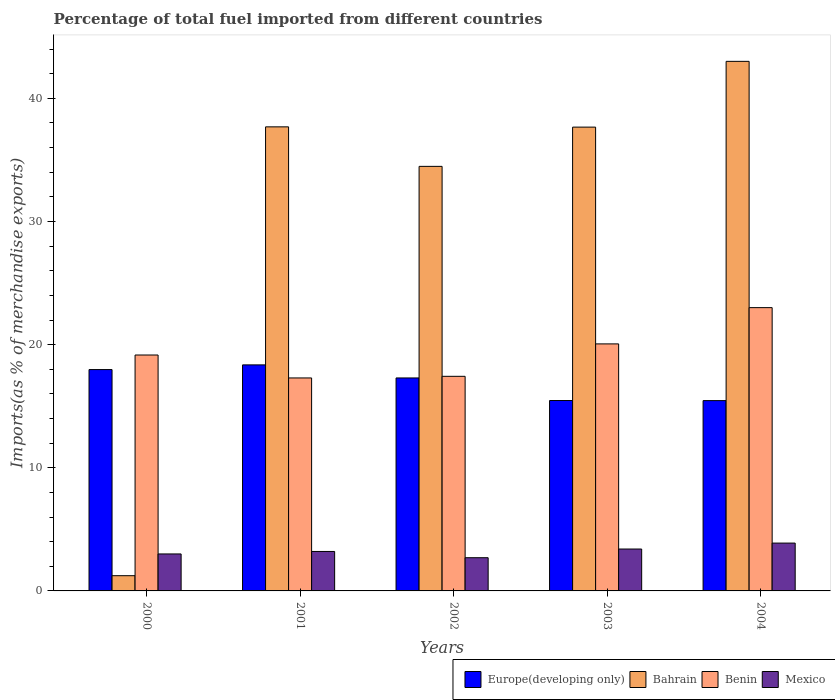How many different coloured bars are there?
Your answer should be compact. 4. How many groups of bars are there?
Your answer should be very brief. 5. Are the number of bars on each tick of the X-axis equal?
Provide a succinct answer. Yes. How many bars are there on the 5th tick from the right?
Offer a terse response. 4. What is the label of the 3rd group of bars from the left?
Your answer should be very brief. 2002. What is the percentage of imports to different countries in Benin in 2001?
Offer a very short reply. 17.3. Across all years, what is the maximum percentage of imports to different countries in Benin?
Your answer should be very brief. 23.01. Across all years, what is the minimum percentage of imports to different countries in Mexico?
Keep it short and to the point. 2.7. What is the total percentage of imports to different countries in Europe(developing only) in the graph?
Offer a very short reply. 84.55. What is the difference between the percentage of imports to different countries in Benin in 2001 and that in 2004?
Provide a short and direct response. -5.71. What is the difference between the percentage of imports to different countries in Bahrain in 2003 and the percentage of imports to different countries in Benin in 2001?
Offer a very short reply. 20.37. What is the average percentage of imports to different countries in Bahrain per year?
Offer a terse response. 30.81. In the year 2004, what is the difference between the percentage of imports to different countries in Bahrain and percentage of imports to different countries in Mexico?
Keep it short and to the point. 39.12. What is the ratio of the percentage of imports to different countries in Mexico in 2003 to that in 2004?
Offer a terse response. 0.88. Is the percentage of imports to different countries in Bahrain in 2000 less than that in 2003?
Ensure brevity in your answer.  Yes. Is the difference between the percentage of imports to different countries in Bahrain in 2003 and 2004 greater than the difference between the percentage of imports to different countries in Mexico in 2003 and 2004?
Your answer should be very brief. No. What is the difference between the highest and the second highest percentage of imports to different countries in Europe(developing only)?
Your answer should be very brief. 0.38. What is the difference between the highest and the lowest percentage of imports to different countries in Mexico?
Your answer should be compact. 1.19. Is the sum of the percentage of imports to different countries in Benin in 2002 and 2003 greater than the maximum percentage of imports to different countries in Europe(developing only) across all years?
Your response must be concise. Yes. What does the 1st bar from the left in 2003 represents?
Your answer should be very brief. Europe(developing only). What does the 2nd bar from the right in 2001 represents?
Your response must be concise. Benin. Is it the case that in every year, the sum of the percentage of imports to different countries in Bahrain and percentage of imports to different countries in Europe(developing only) is greater than the percentage of imports to different countries in Mexico?
Offer a very short reply. Yes. Are all the bars in the graph horizontal?
Give a very brief answer. No. How many years are there in the graph?
Make the answer very short. 5. Are the values on the major ticks of Y-axis written in scientific E-notation?
Your response must be concise. No. Where does the legend appear in the graph?
Keep it short and to the point. Bottom right. What is the title of the graph?
Provide a short and direct response. Percentage of total fuel imported from different countries. What is the label or title of the Y-axis?
Make the answer very short. Imports(as % of merchandise exports). What is the Imports(as % of merchandise exports) of Europe(developing only) in 2000?
Offer a terse response. 17.98. What is the Imports(as % of merchandise exports) of Bahrain in 2000?
Ensure brevity in your answer.  1.24. What is the Imports(as % of merchandise exports) in Benin in 2000?
Provide a short and direct response. 19.16. What is the Imports(as % of merchandise exports) in Mexico in 2000?
Ensure brevity in your answer.  3. What is the Imports(as % of merchandise exports) in Europe(developing only) in 2001?
Your response must be concise. 18.36. What is the Imports(as % of merchandise exports) of Bahrain in 2001?
Offer a terse response. 37.69. What is the Imports(as % of merchandise exports) in Benin in 2001?
Give a very brief answer. 17.3. What is the Imports(as % of merchandise exports) in Mexico in 2001?
Your answer should be very brief. 3.21. What is the Imports(as % of merchandise exports) in Europe(developing only) in 2002?
Provide a short and direct response. 17.3. What is the Imports(as % of merchandise exports) of Bahrain in 2002?
Your response must be concise. 34.48. What is the Imports(as % of merchandise exports) in Benin in 2002?
Your answer should be compact. 17.43. What is the Imports(as % of merchandise exports) of Mexico in 2002?
Your answer should be very brief. 2.7. What is the Imports(as % of merchandise exports) in Europe(developing only) in 2003?
Provide a short and direct response. 15.46. What is the Imports(as % of merchandise exports) of Bahrain in 2003?
Your answer should be very brief. 37.66. What is the Imports(as % of merchandise exports) of Benin in 2003?
Your response must be concise. 20.06. What is the Imports(as % of merchandise exports) of Mexico in 2003?
Make the answer very short. 3.4. What is the Imports(as % of merchandise exports) in Europe(developing only) in 2004?
Provide a succinct answer. 15.45. What is the Imports(as % of merchandise exports) of Bahrain in 2004?
Offer a very short reply. 43.01. What is the Imports(as % of merchandise exports) in Benin in 2004?
Your response must be concise. 23.01. What is the Imports(as % of merchandise exports) in Mexico in 2004?
Your answer should be compact. 3.88. Across all years, what is the maximum Imports(as % of merchandise exports) of Europe(developing only)?
Provide a succinct answer. 18.36. Across all years, what is the maximum Imports(as % of merchandise exports) of Bahrain?
Make the answer very short. 43.01. Across all years, what is the maximum Imports(as % of merchandise exports) in Benin?
Give a very brief answer. 23.01. Across all years, what is the maximum Imports(as % of merchandise exports) in Mexico?
Ensure brevity in your answer.  3.88. Across all years, what is the minimum Imports(as % of merchandise exports) in Europe(developing only)?
Your response must be concise. 15.45. Across all years, what is the minimum Imports(as % of merchandise exports) of Bahrain?
Provide a short and direct response. 1.24. Across all years, what is the minimum Imports(as % of merchandise exports) of Benin?
Give a very brief answer. 17.3. Across all years, what is the minimum Imports(as % of merchandise exports) in Mexico?
Provide a short and direct response. 2.7. What is the total Imports(as % of merchandise exports) of Europe(developing only) in the graph?
Provide a short and direct response. 84.55. What is the total Imports(as % of merchandise exports) in Bahrain in the graph?
Your response must be concise. 154.07. What is the total Imports(as % of merchandise exports) in Benin in the graph?
Your answer should be very brief. 96.95. What is the total Imports(as % of merchandise exports) in Mexico in the graph?
Keep it short and to the point. 16.19. What is the difference between the Imports(as % of merchandise exports) in Europe(developing only) in 2000 and that in 2001?
Make the answer very short. -0.38. What is the difference between the Imports(as % of merchandise exports) in Bahrain in 2000 and that in 2001?
Your response must be concise. -36.45. What is the difference between the Imports(as % of merchandise exports) in Benin in 2000 and that in 2001?
Your response must be concise. 1.86. What is the difference between the Imports(as % of merchandise exports) in Mexico in 2000 and that in 2001?
Keep it short and to the point. -0.2. What is the difference between the Imports(as % of merchandise exports) of Europe(developing only) in 2000 and that in 2002?
Keep it short and to the point. 0.68. What is the difference between the Imports(as % of merchandise exports) of Bahrain in 2000 and that in 2002?
Give a very brief answer. -33.24. What is the difference between the Imports(as % of merchandise exports) of Benin in 2000 and that in 2002?
Your answer should be very brief. 1.73. What is the difference between the Imports(as % of merchandise exports) in Mexico in 2000 and that in 2002?
Provide a succinct answer. 0.31. What is the difference between the Imports(as % of merchandise exports) in Europe(developing only) in 2000 and that in 2003?
Your response must be concise. 2.51. What is the difference between the Imports(as % of merchandise exports) of Bahrain in 2000 and that in 2003?
Offer a very short reply. -36.43. What is the difference between the Imports(as % of merchandise exports) in Benin in 2000 and that in 2003?
Your response must be concise. -0.9. What is the difference between the Imports(as % of merchandise exports) in Mexico in 2000 and that in 2003?
Give a very brief answer. -0.4. What is the difference between the Imports(as % of merchandise exports) in Europe(developing only) in 2000 and that in 2004?
Offer a very short reply. 2.52. What is the difference between the Imports(as % of merchandise exports) in Bahrain in 2000 and that in 2004?
Offer a very short reply. -41.77. What is the difference between the Imports(as % of merchandise exports) in Benin in 2000 and that in 2004?
Offer a terse response. -3.85. What is the difference between the Imports(as % of merchandise exports) in Mexico in 2000 and that in 2004?
Your answer should be very brief. -0.88. What is the difference between the Imports(as % of merchandise exports) of Europe(developing only) in 2001 and that in 2002?
Your response must be concise. 1.06. What is the difference between the Imports(as % of merchandise exports) of Bahrain in 2001 and that in 2002?
Make the answer very short. 3.21. What is the difference between the Imports(as % of merchandise exports) of Benin in 2001 and that in 2002?
Offer a terse response. -0.13. What is the difference between the Imports(as % of merchandise exports) of Mexico in 2001 and that in 2002?
Give a very brief answer. 0.51. What is the difference between the Imports(as % of merchandise exports) of Europe(developing only) in 2001 and that in 2003?
Offer a very short reply. 2.89. What is the difference between the Imports(as % of merchandise exports) of Bahrain in 2001 and that in 2003?
Ensure brevity in your answer.  0.02. What is the difference between the Imports(as % of merchandise exports) of Benin in 2001 and that in 2003?
Your answer should be compact. -2.76. What is the difference between the Imports(as % of merchandise exports) in Mexico in 2001 and that in 2003?
Offer a very short reply. -0.2. What is the difference between the Imports(as % of merchandise exports) of Europe(developing only) in 2001 and that in 2004?
Give a very brief answer. 2.9. What is the difference between the Imports(as % of merchandise exports) of Bahrain in 2001 and that in 2004?
Ensure brevity in your answer.  -5.32. What is the difference between the Imports(as % of merchandise exports) in Benin in 2001 and that in 2004?
Provide a succinct answer. -5.71. What is the difference between the Imports(as % of merchandise exports) of Mexico in 2001 and that in 2004?
Provide a succinct answer. -0.68. What is the difference between the Imports(as % of merchandise exports) of Europe(developing only) in 2002 and that in 2003?
Make the answer very short. 1.83. What is the difference between the Imports(as % of merchandise exports) in Bahrain in 2002 and that in 2003?
Your response must be concise. -3.19. What is the difference between the Imports(as % of merchandise exports) of Benin in 2002 and that in 2003?
Keep it short and to the point. -2.63. What is the difference between the Imports(as % of merchandise exports) in Mexico in 2002 and that in 2003?
Provide a succinct answer. -0.71. What is the difference between the Imports(as % of merchandise exports) of Europe(developing only) in 2002 and that in 2004?
Make the answer very short. 1.84. What is the difference between the Imports(as % of merchandise exports) in Bahrain in 2002 and that in 2004?
Provide a short and direct response. -8.53. What is the difference between the Imports(as % of merchandise exports) in Benin in 2002 and that in 2004?
Your response must be concise. -5.58. What is the difference between the Imports(as % of merchandise exports) of Mexico in 2002 and that in 2004?
Ensure brevity in your answer.  -1.19. What is the difference between the Imports(as % of merchandise exports) of Europe(developing only) in 2003 and that in 2004?
Your response must be concise. 0.01. What is the difference between the Imports(as % of merchandise exports) in Bahrain in 2003 and that in 2004?
Offer a terse response. -5.34. What is the difference between the Imports(as % of merchandise exports) of Benin in 2003 and that in 2004?
Make the answer very short. -2.95. What is the difference between the Imports(as % of merchandise exports) in Mexico in 2003 and that in 2004?
Your answer should be very brief. -0.48. What is the difference between the Imports(as % of merchandise exports) of Europe(developing only) in 2000 and the Imports(as % of merchandise exports) of Bahrain in 2001?
Give a very brief answer. -19.71. What is the difference between the Imports(as % of merchandise exports) of Europe(developing only) in 2000 and the Imports(as % of merchandise exports) of Benin in 2001?
Provide a short and direct response. 0.68. What is the difference between the Imports(as % of merchandise exports) of Europe(developing only) in 2000 and the Imports(as % of merchandise exports) of Mexico in 2001?
Keep it short and to the point. 14.77. What is the difference between the Imports(as % of merchandise exports) in Bahrain in 2000 and the Imports(as % of merchandise exports) in Benin in 2001?
Your response must be concise. -16.06. What is the difference between the Imports(as % of merchandise exports) in Bahrain in 2000 and the Imports(as % of merchandise exports) in Mexico in 2001?
Provide a short and direct response. -1.97. What is the difference between the Imports(as % of merchandise exports) in Benin in 2000 and the Imports(as % of merchandise exports) in Mexico in 2001?
Offer a terse response. 15.95. What is the difference between the Imports(as % of merchandise exports) in Europe(developing only) in 2000 and the Imports(as % of merchandise exports) in Bahrain in 2002?
Offer a terse response. -16.5. What is the difference between the Imports(as % of merchandise exports) in Europe(developing only) in 2000 and the Imports(as % of merchandise exports) in Benin in 2002?
Keep it short and to the point. 0.55. What is the difference between the Imports(as % of merchandise exports) in Europe(developing only) in 2000 and the Imports(as % of merchandise exports) in Mexico in 2002?
Your answer should be very brief. 15.28. What is the difference between the Imports(as % of merchandise exports) in Bahrain in 2000 and the Imports(as % of merchandise exports) in Benin in 2002?
Your answer should be compact. -16.19. What is the difference between the Imports(as % of merchandise exports) of Bahrain in 2000 and the Imports(as % of merchandise exports) of Mexico in 2002?
Give a very brief answer. -1.46. What is the difference between the Imports(as % of merchandise exports) of Benin in 2000 and the Imports(as % of merchandise exports) of Mexico in 2002?
Your response must be concise. 16.46. What is the difference between the Imports(as % of merchandise exports) in Europe(developing only) in 2000 and the Imports(as % of merchandise exports) in Bahrain in 2003?
Your response must be concise. -19.69. What is the difference between the Imports(as % of merchandise exports) in Europe(developing only) in 2000 and the Imports(as % of merchandise exports) in Benin in 2003?
Offer a terse response. -2.08. What is the difference between the Imports(as % of merchandise exports) of Europe(developing only) in 2000 and the Imports(as % of merchandise exports) of Mexico in 2003?
Your answer should be very brief. 14.57. What is the difference between the Imports(as % of merchandise exports) of Bahrain in 2000 and the Imports(as % of merchandise exports) of Benin in 2003?
Make the answer very short. -18.82. What is the difference between the Imports(as % of merchandise exports) of Bahrain in 2000 and the Imports(as % of merchandise exports) of Mexico in 2003?
Ensure brevity in your answer.  -2.17. What is the difference between the Imports(as % of merchandise exports) of Benin in 2000 and the Imports(as % of merchandise exports) of Mexico in 2003?
Give a very brief answer. 15.76. What is the difference between the Imports(as % of merchandise exports) of Europe(developing only) in 2000 and the Imports(as % of merchandise exports) of Bahrain in 2004?
Provide a succinct answer. -25.03. What is the difference between the Imports(as % of merchandise exports) of Europe(developing only) in 2000 and the Imports(as % of merchandise exports) of Benin in 2004?
Give a very brief answer. -5.03. What is the difference between the Imports(as % of merchandise exports) of Europe(developing only) in 2000 and the Imports(as % of merchandise exports) of Mexico in 2004?
Your response must be concise. 14.09. What is the difference between the Imports(as % of merchandise exports) of Bahrain in 2000 and the Imports(as % of merchandise exports) of Benin in 2004?
Ensure brevity in your answer.  -21.77. What is the difference between the Imports(as % of merchandise exports) in Bahrain in 2000 and the Imports(as % of merchandise exports) in Mexico in 2004?
Provide a short and direct response. -2.65. What is the difference between the Imports(as % of merchandise exports) in Benin in 2000 and the Imports(as % of merchandise exports) in Mexico in 2004?
Provide a succinct answer. 15.27. What is the difference between the Imports(as % of merchandise exports) in Europe(developing only) in 2001 and the Imports(as % of merchandise exports) in Bahrain in 2002?
Provide a succinct answer. -16.12. What is the difference between the Imports(as % of merchandise exports) in Europe(developing only) in 2001 and the Imports(as % of merchandise exports) in Benin in 2002?
Your response must be concise. 0.93. What is the difference between the Imports(as % of merchandise exports) of Europe(developing only) in 2001 and the Imports(as % of merchandise exports) of Mexico in 2002?
Make the answer very short. 15.66. What is the difference between the Imports(as % of merchandise exports) of Bahrain in 2001 and the Imports(as % of merchandise exports) of Benin in 2002?
Keep it short and to the point. 20.26. What is the difference between the Imports(as % of merchandise exports) in Bahrain in 2001 and the Imports(as % of merchandise exports) in Mexico in 2002?
Offer a terse response. 34.99. What is the difference between the Imports(as % of merchandise exports) in Benin in 2001 and the Imports(as % of merchandise exports) in Mexico in 2002?
Offer a very short reply. 14.6. What is the difference between the Imports(as % of merchandise exports) in Europe(developing only) in 2001 and the Imports(as % of merchandise exports) in Bahrain in 2003?
Offer a very short reply. -19.31. What is the difference between the Imports(as % of merchandise exports) of Europe(developing only) in 2001 and the Imports(as % of merchandise exports) of Benin in 2003?
Provide a short and direct response. -1.7. What is the difference between the Imports(as % of merchandise exports) in Europe(developing only) in 2001 and the Imports(as % of merchandise exports) in Mexico in 2003?
Your answer should be very brief. 14.95. What is the difference between the Imports(as % of merchandise exports) of Bahrain in 2001 and the Imports(as % of merchandise exports) of Benin in 2003?
Offer a very short reply. 17.63. What is the difference between the Imports(as % of merchandise exports) of Bahrain in 2001 and the Imports(as % of merchandise exports) of Mexico in 2003?
Your answer should be compact. 34.28. What is the difference between the Imports(as % of merchandise exports) in Benin in 2001 and the Imports(as % of merchandise exports) in Mexico in 2003?
Your answer should be compact. 13.89. What is the difference between the Imports(as % of merchandise exports) of Europe(developing only) in 2001 and the Imports(as % of merchandise exports) of Bahrain in 2004?
Keep it short and to the point. -24.65. What is the difference between the Imports(as % of merchandise exports) in Europe(developing only) in 2001 and the Imports(as % of merchandise exports) in Benin in 2004?
Make the answer very short. -4.65. What is the difference between the Imports(as % of merchandise exports) of Europe(developing only) in 2001 and the Imports(as % of merchandise exports) of Mexico in 2004?
Ensure brevity in your answer.  14.47. What is the difference between the Imports(as % of merchandise exports) in Bahrain in 2001 and the Imports(as % of merchandise exports) in Benin in 2004?
Offer a very short reply. 14.68. What is the difference between the Imports(as % of merchandise exports) in Bahrain in 2001 and the Imports(as % of merchandise exports) in Mexico in 2004?
Provide a succinct answer. 33.8. What is the difference between the Imports(as % of merchandise exports) of Benin in 2001 and the Imports(as % of merchandise exports) of Mexico in 2004?
Provide a short and direct response. 13.41. What is the difference between the Imports(as % of merchandise exports) in Europe(developing only) in 2002 and the Imports(as % of merchandise exports) in Bahrain in 2003?
Make the answer very short. -20.37. What is the difference between the Imports(as % of merchandise exports) of Europe(developing only) in 2002 and the Imports(as % of merchandise exports) of Benin in 2003?
Offer a terse response. -2.76. What is the difference between the Imports(as % of merchandise exports) of Europe(developing only) in 2002 and the Imports(as % of merchandise exports) of Mexico in 2003?
Your response must be concise. 13.89. What is the difference between the Imports(as % of merchandise exports) of Bahrain in 2002 and the Imports(as % of merchandise exports) of Benin in 2003?
Ensure brevity in your answer.  14.42. What is the difference between the Imports(as % of merchandise exports) of Bahrain in 2002 and the Imports(as % of merchandise exports) of Mexico in 2003?
Offer a very short reply. 31.07. What is the difference between the Imports(as % of merchandise exports) of Benin in 2002 and the Imports(as % of merchandise exports) of Mexico in 2003?
Give a very brief answer. 14.02. What is the difference between the Imports(as % of merchandise exports) of Europe(developing only) in 2002 and the Imports(as % of merchandise exports) of Bahrain in 2004?
Make the answer very short. -25.71. What is the difference between the Imports(as % of merchandise exports) in Europe(developing only) in 2002 and the Imports(as % of merchandise exports) in Benin in 2004?
Provide a short and direct response. -5.71. What is the difference between the Imports(as % of merchandise exports) of Europe(developing only) in 2002 and the Imports(as % of merchandise exports) of Mexico in 2004?
Offer a very short reply. 13.41. What is the difference between the Imports(as % of merchandise exports) of Bahrain in 2002 and the Imports(as % of merchandise exports) of Benin in 2004?
Offer a terse response. 11.47. What is the difference between the Imports(as % of merchandise exports) in Bahrain in 2002 and the Imports(as % of merchandise exports) in Mexico in 2004?
Offer a terse response. 30.59. What is the difference between the Imports(as % of merchandise exports) of Benin in 2002 and the Imports(as % of merchandise exports) of Mexico in 2004?
Give a very brief answer. 13.54. What is the difference between the Imports(as % of merchandise exports) of Europe(developing only) in 2003 and the Imports(as % of merchandise exports) of Bahrain in 2004?
Ensure brevity in your answer.  -27.54. What is the difference between the Imports(as % of merchandise exports) in Europe(developing only) in 2003 and the Imports(as % of merchandise exports) in Benin in 2004?
Give a very brief answer. -7.54. What is the difference between the Imports(as % of merchandise exports) of Europe(developing only) in 2003 and the Imports(as % of merchandise exports) of Mexico in 2004?
Give a very brief answer. 11.58. What is the difference between the Imports(as % of merchandise exports) of Bahrain in 2003 and the Imports(as % of merchandise exports) of Benin in 2004?
Give a very brief answer. 14.66. What is the difference between the Imports(as % of merchandise exports) of Bahrain in 2003 and the Imports(as % of merchandise exports) of Mexico in 2004?
Make the answer very short. 33.78. What is the difference between the Imports(as % of merchandise exports) of Benin in 2003 and the Imports(as % of merchandise exports) of Mexico in 2004?
Offer a terse response. 16.18. What is the average Imports(as % of merchandise exports) of Europe(developing only) per year?
Offer a terse response. 16.91. What is the average Imports(as % of merchandise exports) of Bahrain per year?
Provide a short and direct response. 30.81. What is the average Imports(as % of merchandise exports) of Benin per year?
Offer a terse response. 19.39. What is the average Imports(as % of merchandise exports) in Mexico per year?
Your answer should be compact. 3.24. In the year 2000, what is the difference between the Imports(as % of merchandise exports) of Europe(developing only) and Imports(as % of merchandise exports) of Bahrain?
Provide a short and direct response. 16.74. In the year 2000, what is the difference between the Imports(as % of merchandise exports) in Europe(developing only) and Imports(as % of merchandise exports) in Benin?
Offer a very short reply. -1.18. In the year 2000, what is the difference between the Imports(as % of merchandise exports) in Europe(developing only) and Imports(as % of merchandise exports) in Mexico?
Keep it short and to the point. 14.97. In the year 2000, what is the difference between the Imports(as % of merchandise exports) in Bahrain and Imports(as % of merchandise exports) in Benin?
Your response must be concise. -17.92. In the year 2000, what is the difference between the Imports(as % of merchandise exports) of Bahrain and Imports(as % of merchandise exports) of Mexico?
Your answer should be very brief. -1.77. In the year 2000, what is the difference between the Imports(as % of merchandise exports) in Benin and Imports(as % of merchandise exports) in Mexico?
Offer a terse response. 16.16. In the year 2001, what is the difference between the Imports(as % of merchandise exports) in Europe(developing only) and Imports(as % of merchandise exports) in Bahrain?
Offer a very short reply. -19.33. In the year 2001, what is the difference between the Imports(as % of merchandise exports) in Europe(developing only) and Imports(as % of merchandise exports) in Benin?
Provide a short and direct response. 1.06. In the year 2001, what is the difference between the Imports(as % of merchandise exports) in Europe(developing only) and Imports(as % of merchandise exports) in Mexico?
Your response must be concise. 15.15. In the year 2001, what is the difference between the Imports(as % of merchandise exports) of Bahrain and Imports(as % of merchandise exports) of Benin?
Provide a succinct answer. 20.39. In the year 2001, what is the difference between the Imports(as % of merchandise exports) of Bahrain and Imports(as % of merchandise exports) of Mexico?
Ensure brevity in your answer.  34.48. In the year 2001, what is the difference between the Imports(as % of merchandise exports) of Benin and Imports(as % of merchandise exports) of Mexico?
Your answer should be compact. 14.09. In the year 2002, what is the difference between the Imports(as % of merchandise exports) of Europe(developing only) and Imports(as % of merchandise exports) of Bahrain?
Provide a succinct answer. -17.18. In the year 2002, what is the difference between the Imports(as % of merchandise exports) of Europe(developing only) and Imports(as % of merchandise exports) of Benin?
Your answer should be compact. -0.13. In the year 2002, what is the difference between the Imports(as % of merchandise exports) of Europe(developing only) and Imports(as % of merchandise exports) of Mexico?
Your answer should be very brief. 14.6. In the year 2002, what is the difference between the Imports(as % of merchandise exports) of Bahrain and Imports(as % of merchandise exports) of Benin?
Give a very brief answer. 17.05. In the year 2002, what is the difference between the Imports(as % of merchandise exports) of Bahrain and Imports(as % of merchandise exports) of Mexico?
Provide a succinct answer. 31.78. In the year 2002, what is the difference between the Imports(as % of merchandise exports) of Benin and Imports(as % of merchandise exports) of Mexico?
Your answer should be very brief. 14.73. In the year 2003, what is the difference between the Imports(as % of merchandise exports) in Europe(developing only) and Imports(as % of merchandise exports) in Bahrain?
Keep it short and to the point. -22.2. In the year 2003, what is the difference between the Imports(as % of merchandise exports) of Europe(developing only) and Imports(as % of merchandise exports) of Benin?
Your response must be concise. -4.6. In the year 2003, what is the difference between the Imports(as % of merchandise exports) of Europe(developing only) and Imports(as % of merchandise exports) of Mexico?
Keep it short and to the point. 12.06. In the year 2003, what is the difference between the Imports(as % of merchandise exports) in Bahrain and Imports(as % of merchandise exports) in Benin?
Your response must be concise. 17.6. In the year 2003, what is the difference between the Imports(as % of merchandise exports) in Bahrain and Imports(as % of merchandise exports) in Mexico?
Provide a succinct answer. 34.26. In the year 2003, what is the difference between the Imports(as % of merchandise exports) in Benin and Imports(as % of merchandise exports) in Mexico?
Your answer should be very brief. 16.66. In the year 2004, what is the difference between the Imports(as % of merchandise exports) in Europe(developing only) and Imports(as % of merchandise exports) in Bahrain?
Provide a short and direct response. -27.55. In the year 2004, what is the difference between the Imports(as % of merchandise exports) in Europe(developing only) and Imports(as % of merchandise exports) in Benin?
Your answer should be compact. -7.55. In the year 2004, what is the difference between the Imports(as % of merchandise exports) of Europe(developing only) and Imports(as % of merchandise exports) of Mexico?
Ensure brevity in your answer.  11.57. In the year 2004, what is the difference between the Imports(as % of merchandise exports) in Bahrain and Imports(as % of merchandise exports) in Benin?
Make the answer very short. 20. In the year 2004, what is the difference between the Imports(as % of merchandise exports) in Bahrain and Imports(as % of merchandise exports) in Mexico?
Offer a very short reply. 39.12. In the year 2004, what is the difference between the Imports(as % of merchandise exports) in Benin and Imports(as % of merchandise exports) in Mexico?
Your answer should be compact. 19.12. What is the ratio of the Imports(as % of merchandise exports) of Europe(developing only) in 2000 to that in 2001?
Make the answer very short. 0.98. What is the ratio of the Imports(as % of merchandise exports) of Bahrain in 2000 to that in 2001?
Provide a succinct answer. 0.03. What is the ratio of the Imports(as % of merchandise exports) in Benin in 2000 to that in 2001?
Make the answer very short. 1.11. What is the ratio of the Imports(as % of merchandise exports) of Mexico in 2000 to that in 2001?
Your answer should be compact. 0.94. What is the ratio of the Imports(as % of merchandise exports) in Europe(developing only) in 2000 to that in 2002?
Offer a very short reply. 1.04. What is the ratio of the Imports(as % of merchandise exports) in Bahrain in 2000 to that in 2002?
Provide a short and direct response. 0.04. What is the ratio of the Imports(as % of merchandise exports) of Benin in 2000 to that in 2002?
Ensure brevity in your answer.  1.1. What is the ratio of the Imports(as % of merchandise exports) in Mexico in 2000 to that in 2002?
Ensure brevity in your answer.  1.11. What is the ratio of the Imports(as % of merchandise exports) of Europe(developing only) in 2000 to that in 2003?
Ensure brevity in your answer.  1.16. What is the ratio of the Imports(as % of merchandise exports) in Bahrain in 2000 to that in 2003?
Make the answer very short. 0.03. What is the ratio of the Imports(as % of merchandise exports) in Benin in 2000 to that in 2003?
Offer a terse response. 0.96. What is the ratio of the Imports(as % of merchandise exports) in Mexico in 2000 to that in 2003?
Make the answer very short. 0.88. What is the ratio of the Imports(as % of merchandise exports) of Europe(developing only) in 2000 to that in 2004?
Ensure brevity in your answer.  1.16. What is the ratio of the Imports(as % of merchandise exports) in Bahrain in 2000 to that in 2004?
Give a very brief answer. 0.03. What is the ratio of the Imports(as % of merchandise exports) in Benin in 2000 to that in 2004?
Your answer should be very brief. 0.83. What is the ratio of the Imports(as % of merchandise exports) of Mexico in 2000 to that in 2004?
Provide a succinct answer. 0.77. What is the ratio of the Imports(as % of merchandise exports) of Europe(developing only) in 2001 to that in 2002?
Offer a very short reply. 1.06. What is the ratio of the Imports(as % of merchandise exports) of Bahrain in 2001 to that in 2002?
Ensure brevity in your answer.  1.09. What is the ratio of the Imports(as % of merchandise exports) of Benin in 2001 to that in 2002?
Offer a very short reply. 0.99. What is the ratio of the Imports(as % of merchandise exports) of Mexico in 2001 to that in 2002?
Ensure brevity in your answer.  1.19. What is the ratio of the Imports(as % of merchandise exports) in Europe(developing only) in 2001 to that in 2003?
Ensure brevity in your answer.  1.19. What is the ratio of the Imports(as % of merchandise exports) in Bahrain in 2001 to that in 2003?
Offer a terse response. 1. What is the ratio of the Imports(as % of merchandise exports) of Benin in 2001 to that in 2003?
Provide a short and direct response. 0.86. What is the ratio of the Imports(as % of merchandise exports) in Mexico in 2001 to that in 2003?
Provide a succinct answer. 0.94. What is the ratio of the Imports(as % of merchandise exports) of Europe(developing only) in 2001 to that in 2004?
Your answer should be very brief. 1.19. What is the ratio of the Imports(as % of merchandise exports) of Bahrain in 2001 to that in 2004?
Make the answer very short. 0.88. What is the ratio of the Imports(as % of merchandise exports) in Benin in 2001 to that in 2004?
Keep it short and to the point. 0.75. What is the ratio of the Imports(as % of merchandise exports) of Mexico in 2001 to that in 2004?
Ensure brevity in your answer.  0.83. What is the ratio of the Imports(as % of merchandise exports) of Europe(developing only) in 2002 to that in 2003?
Make the answer very short. 1.12. What is the ratio of the Imports(as % of merchandise exports) of Bahrain in 2002 to that in 2003?
Make the answer very short. 0.92. What is the ratio of the Imports(as % of merchandise exports) of Benin in 2002 to that in 2003?
Offer a terse response. 0.87. What is the ratio of the Imports(as % of merchandise exports) in Mexico in 2002 to that in 2003?
Provide a succinct answer. 0.79. What is the ratio of the Imports(as % of merchandise exports) in Europe(developing only) in 2002 to that in 2004?
Your answer should be compact. 1.12. What is the ratio of the Imports(as % of merchandise exports) in Bahrain in 2002 to that in 2004?
Provide a succinct answer. 0.8. What is the ratio of the Imports(as % of merchandise exports) of Benin in 2002 to that in 2004?
Make the answer very short. 0.76. What is the ratio of the Imports(as % of merchandise exports) of Mexico in 2002 to that in 2004?
Your answer should be compact. 0.69. What is the ratio of the Imports(as % of merchandise exports) of Europe(developing only) in 2003 to that in 2004?
Offer a terse response. 1. What is the ratio of the Imports(as % of merchandise exports) in Bahrain in 2003 to that in 2004?
Provide a short and direct response. 0.88. What is the ratio of the Imports(as % of merchandise exports) of Benin in 2003 to that in 2004?
Provide a succinct answer. 0.87. What is the ratio of the Imports(as % of merchandise exports) in Mexico in 2003 to that in 2004?
Ensure brevity in your answer.  0.88. What is the difference between the highest and the second highest Imports(as % of merchandise exports) in Europe(developing only)?
Provide a short and direct response. 0.38. What is the difference between the highest and the second highest Imports(as % of merchandise exports) in Bahrain?
Offer a terse response. 5.32. What is the difference between the highest and the second highest Imports(as % of merchandise exports) in Benin?
Give a very brief answer. 2.95. What is the difference between the highest and the second highest Imports(as % of merchandise exports) in Mexico?
Your answer should be very brief. 0.48. What is the difference between the highest and the lowest Imports(as % of merchandise exports) in Europe(developing only)?
Offer a terse response. 2.9. What is the difference between the highest and the lowest Imports(as % of merchandise exports) of Bahrain?
Keep it short and to the point. 41.77. What is the difference between the highest and the lowest Imports(as % of merchandise exports) of Benin?
Provide a short and direct response. 5.71. What is the difference between the highest and the lowest Imports(as % of merchandise exports) in Mexico?
Keep it short and to the point. 1.19. 